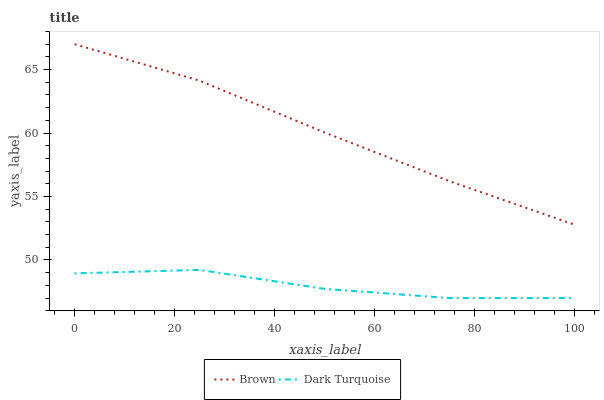Does Dark Turquoise have the minimum area under the curve?
Answer yes or no. Yes. Does Brown have the maximum area under the curve?
Answer yes or no. Yes. Does Dark Turquoise have the maximum area under the curve?
Answer yes or no. No. Is Brown the smoothest?
Answer yes or no. Yes. Is Dark Turquoise the roughest?
Answer yes or no. Yes. Is Dark Turquoise the smoothest?
Answer yes or no. No. Does Dark Turquoise have the lowest value?
Answer yes or no. Yes. Does Brown have the highest value?
Answer yes or no. Yes. Does Dark Turquoise have the highest value?
Answer yes or no. No. Is Dark Turquoise less than Brown?
Answer yes or no. Yes. Is Brown greater than Dark Turquoise?
Answer yes or no. Yes. Does Dark Turquoise intersect Brown?
Answer yes or no. No. 